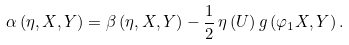<formula> <loc_0><loc_0><loc_500><loc_500>\alpha \left ( \eta , X , Y \right ) = \beta \left ( \eta , X , Y \right ) - \frac { 1 } { 2 } \, \eta \left ( U \right ) g \left ( \varphi _ { 1 } X , Y \right ) .</formula> 